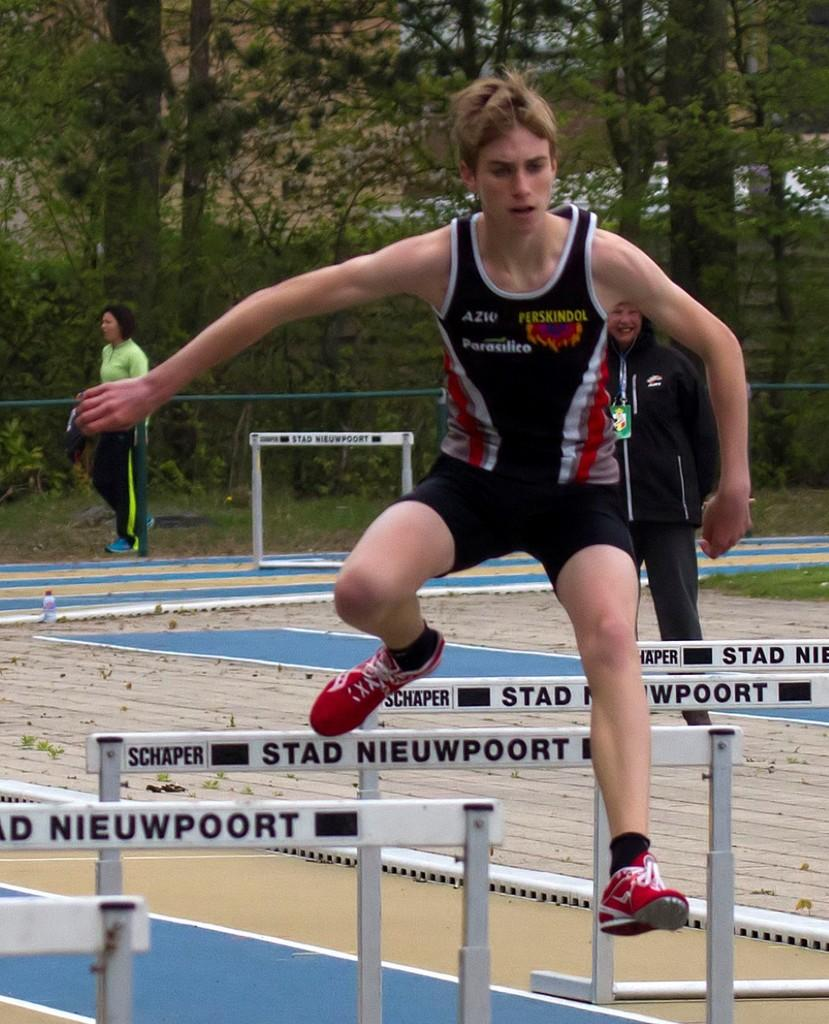Provide a one-sentence caption for the provided image. A male athlete jumps hurdles with the name Schaper Stad Nieuwpoort on them. 